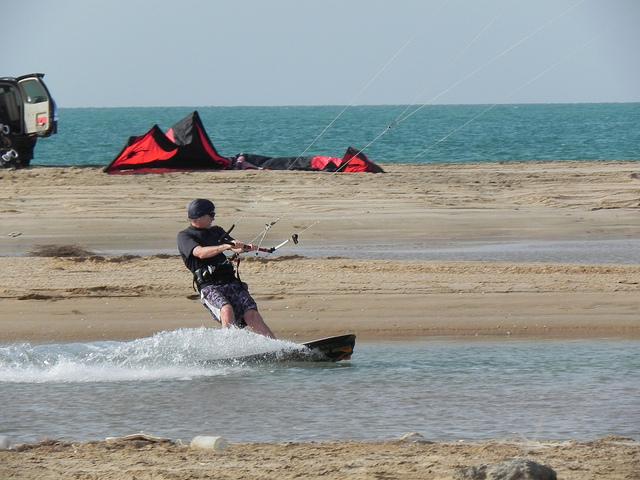How deep is the water?
Give a very brief answer. 2 feet. What is the man on?
Be succinct. Surfboard. Is the man swimming?
Be succinct. No. 